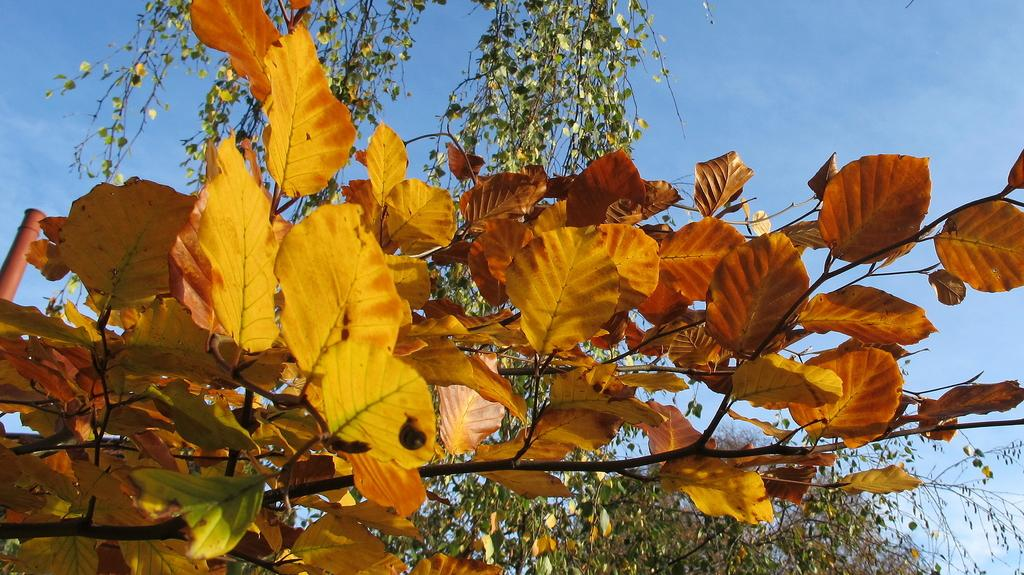Where was the image taken? The image was taken outside. What can be seen in the foreground of the image? There are leaves and stems of trees in the foreground. What is visible in the background of the image? There is a sky visible in the background. What type of toothbrush is hanging from the tree in the image? There is no toothbrush present in the image; it features leaves and stems of trees in the foreground and a sky in the background. 